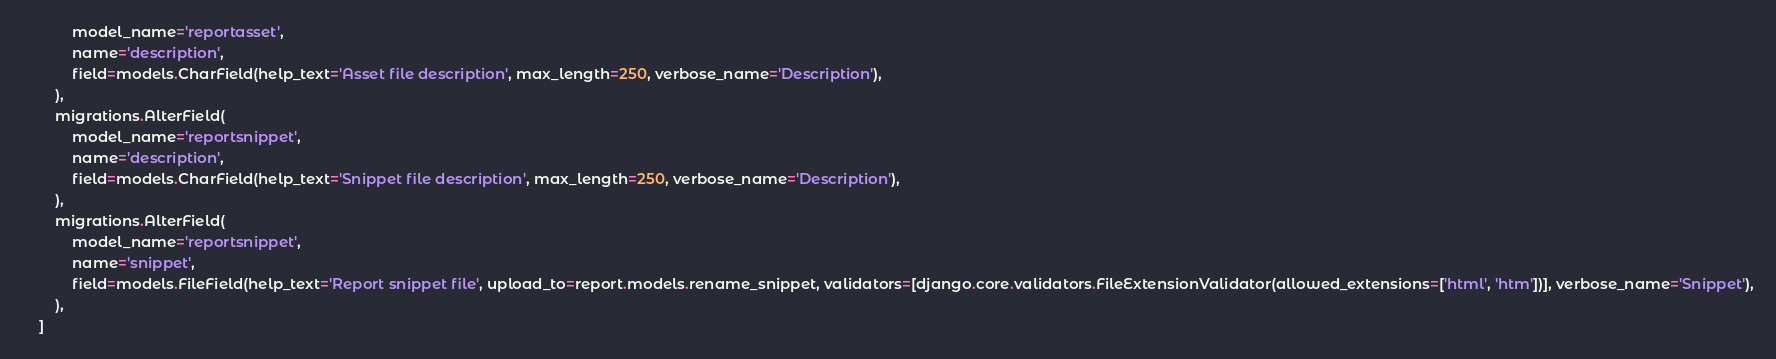Convert code to text. <code><loc_0><loc_0><loc_500><loc_500><_Python_>            model_name='reportasset',
            name='description',
            field=models.CharField(help_text='Asset file description', max_length=250, verbose_name='Description'),
        ),
        migrations.AlterField(
            model_name='reportsnippet',
            name='description',
            field=models.CharField(help_text='Snippet file description', max_length=250, verbose_name='Description'),
        ),
        migrations.AlterField(
            model_name='reportsnippet',
            name='snippet',
            field=models.FileField(help_text='Report snippet file', upload_to=report.models.rename_snippet, validators=[django.core.validators.FileExtensionValidator(allowed_extensions=['html', 'htm'])], verbose_name='Snippet'),
        ),
    ]
</code> 